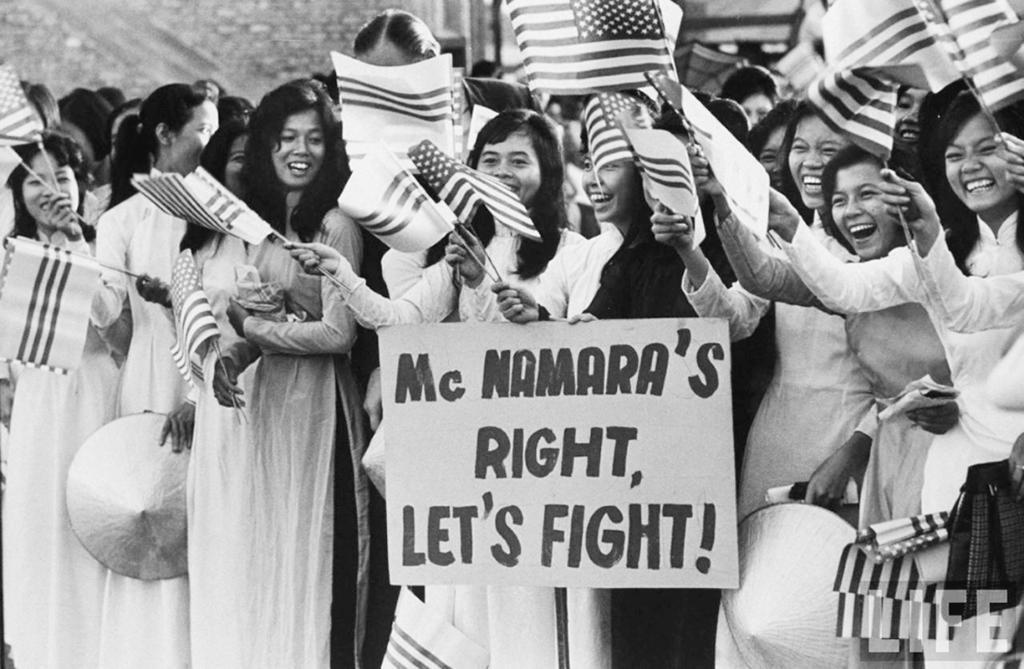In one or two sentences, can you explain what this image depicts? Here we can see group of people standing and holding flags with sticks and we can see board. 